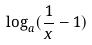<formula> <loc_0><loc_0><loc_500><loc_500>\log _ { a } ( \frac { 1 } { x } - 1 )</formula> 